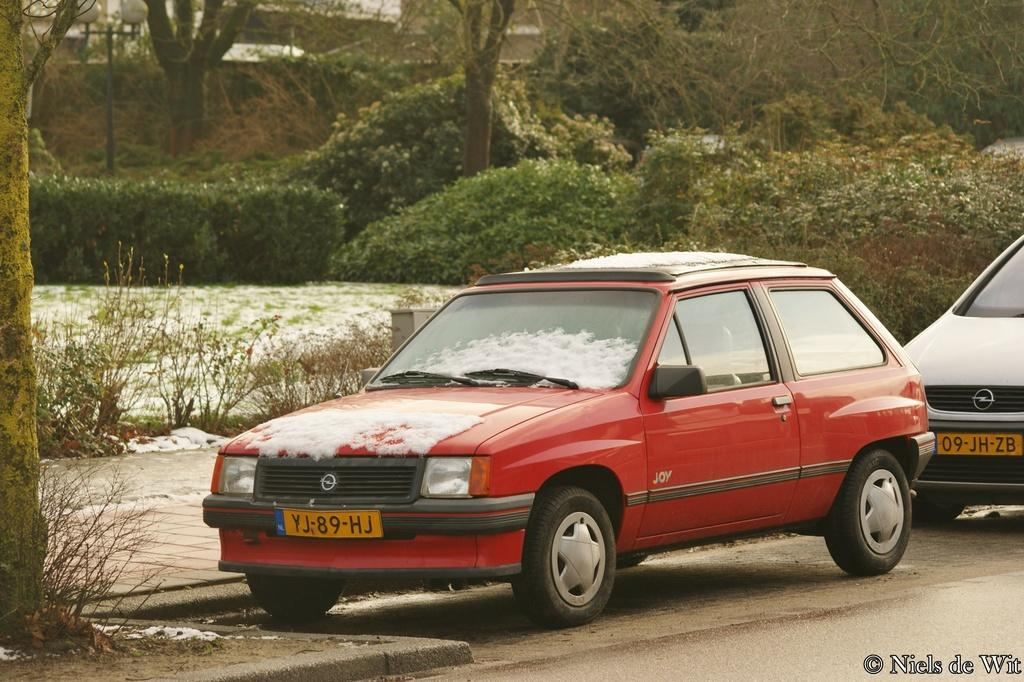<image>
Relay a brief, clear account of the picture shown. A red car with the license plate number YJ-89-HJ 